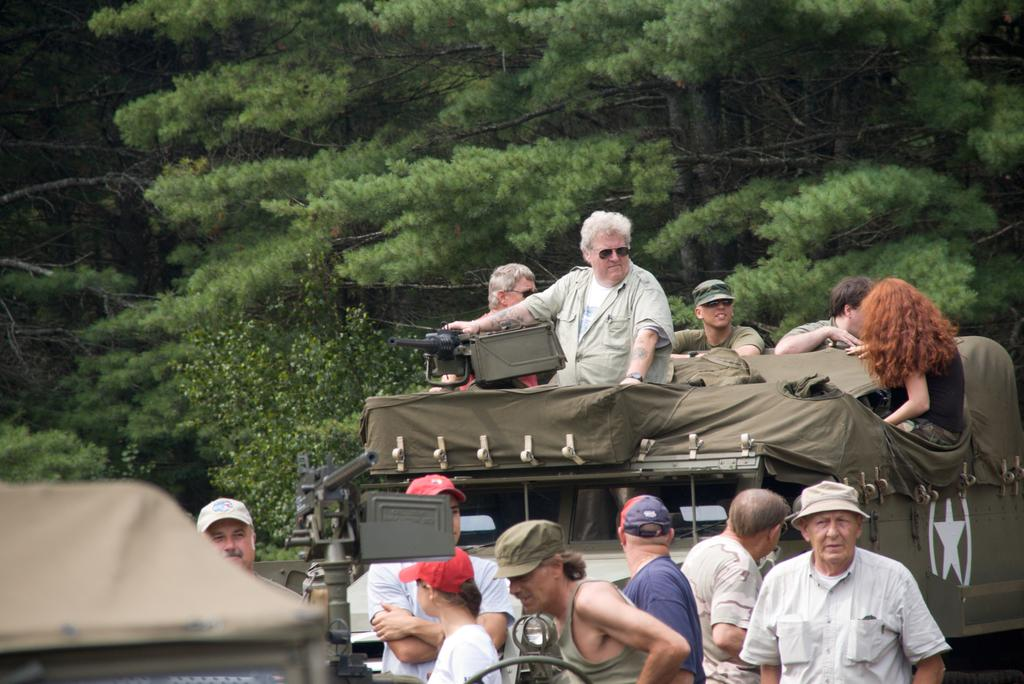Who can be seen in the image? There are people in the image. What are some of the people wearing? Some people are wearing caps. What are the people in the middle of the image doing? They are riding a vehicle. What can be seen in the distance in the image? There are trees visible in the background of the image. Where is the goat grazing in the image? There is no goat present in the image. What type of toad can be seen hopping near the trees in the background? There is no toad present in the image; only people and trees are visible. 